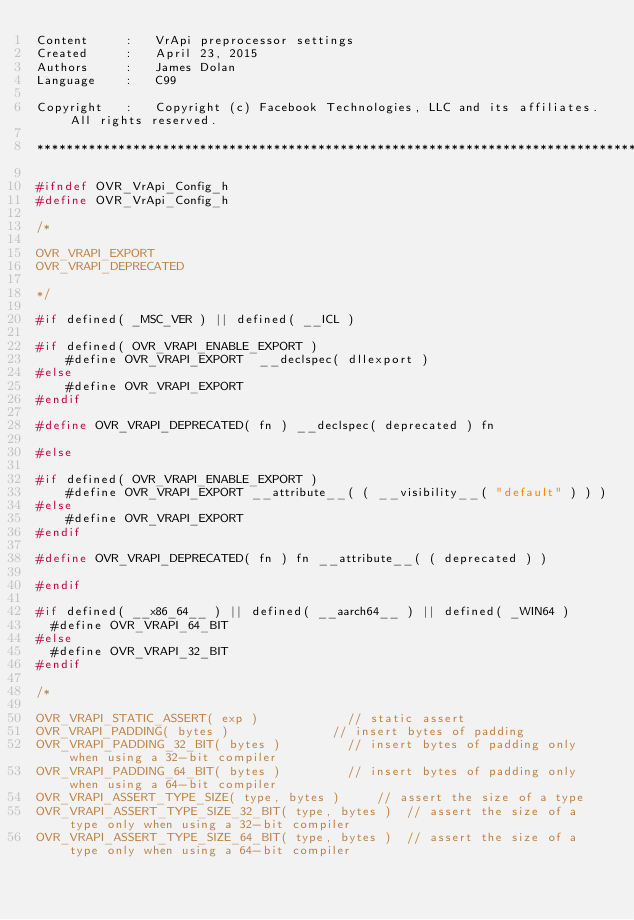<code> <loc_0><loc_0><loc_500><loc_500><_C_>Content     :   VrApi preprocessor settings
Created     :   April 23, 2015
Authors     :   James Dolan
Language    :   C99

Copyright   :   Copyright (c) Facebook Technologies, LLC and its affiliates. All rights reserved.

*************************************************************************************/

#ifndef OVR_VrApi_Config_h
#define OVR_VrApi_Config_h

/*

OVR_VRAPI_EXPORT
OVR_VRAPI_DEPRECATED

*/

#if defined( _MSC_VER ) || defined( __ICL )

#if defined( OVR_VRAPI_ENABLE_EXPORT )
    #define OVR_VRAPI_EXPORT  __declspec( dllexport )
#else
    #define OVR_VRAPI_EXPORT
#endif

#define OVR_VRAPI_DEPRECATED( fn ) __declspec( deprecated ) fn

#else

#if defined( OVR_VRAPI_ENABLE_EXPORT )
    #define OVR_VRAPI_EXPORT __attribute__( ( __visibility__( "default" ) ) )
#else
    #define OVR_VRAPI_EXPORT 
#endif

#define OVR_VRAPI_DEPRECATED( fn ) fn __attribute__( ( deprecated ) )

#endif

#if defined( __x86_64__ ) || defined( __aarch64__ ) || defined( _WIN64 )
	#define OVR_VRAPI_64_BIT
#else
	#define OVR_VRAPI_32_BIT
#endif

/*

OVR_VRAPI_STATIC_ASSERT( exp )						// static assert
OVR_VRAPI_PADDING( bytes )							// insert bytes of padding
OVR_VRAPI_PADDING_32_BIT( bytes )					// insert bytes of padding only when using a 32-bit compiler
OVR_VRAPI_PADDING_64_BIT( bytes )					// insert bytes of padding only when using a 64-bit compiler
OVR_VRAPI_ASSERT_TYPE_SIZE( type, bytes )			// assert the size of a type
OVR_VRAPI_ASSERT_TYPE_SIZE_32_BIT( type, bytes )	// assert the size of a type only when using a 32-bit compiler
OVR_VRAPI_ASSERT_TYPE_SIZE_64_BIT( type, bytes )	// assert the size of a type only when using a 64-bit compiler</code> 